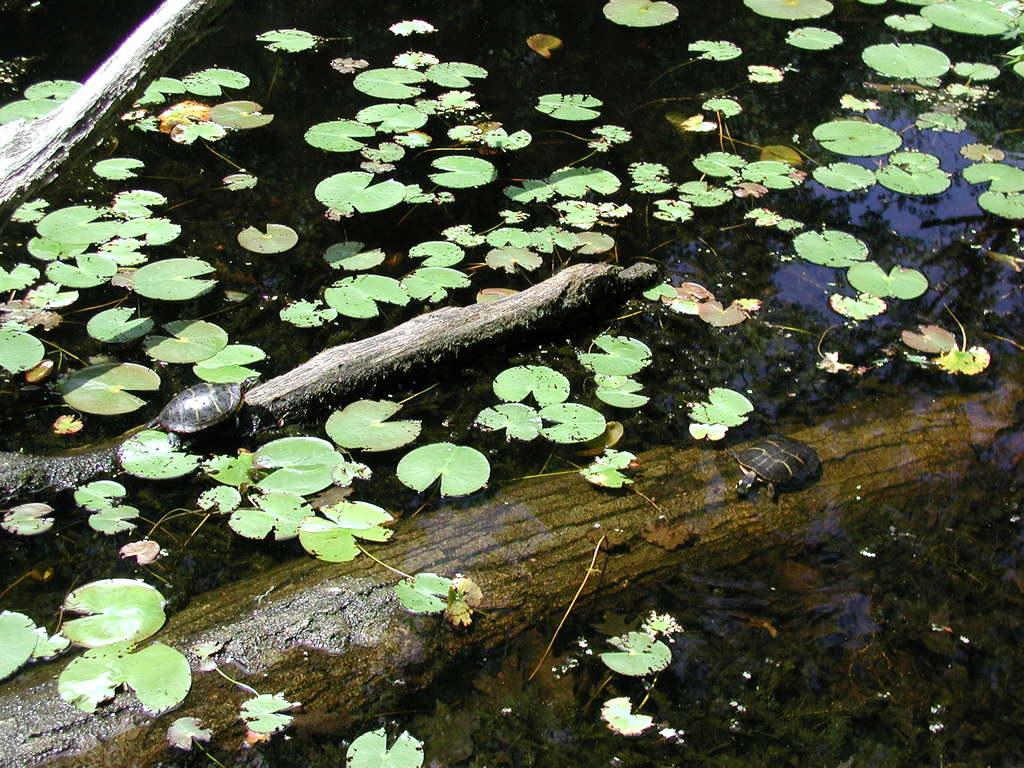How many tortoises are in the image? There are two tortoises in the image. What are the tortoises standing on? The tortoises are on wooden stems. Where are the wooden stems located? The wooden stems are in the water. What else can be seen floating on the water? There are some leaves on the water. What type of plane can be seen flying over the tortoises in the image? There is no plane visible in the image; it only features two tortoises on wooden stems in the water. 